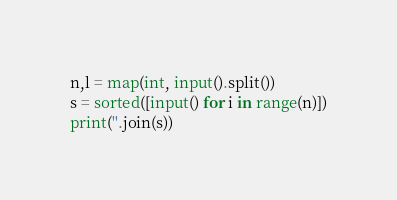<code> <loc_0><loc_0><loc_500><loc_500><_Python_>n,l = map(int, input().split())
s = sorted([input() for i in range(n)])
print(''.join(s))</code> 